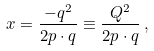<formula> <loc_0><loc_0><loc_500><loc_500>x = \frac { - q ^ { 2 } } { 2 p \cdot q } \equiv \frac { Q ^ { 2 } } { 2 p \cdot q } \, ,</formula> 